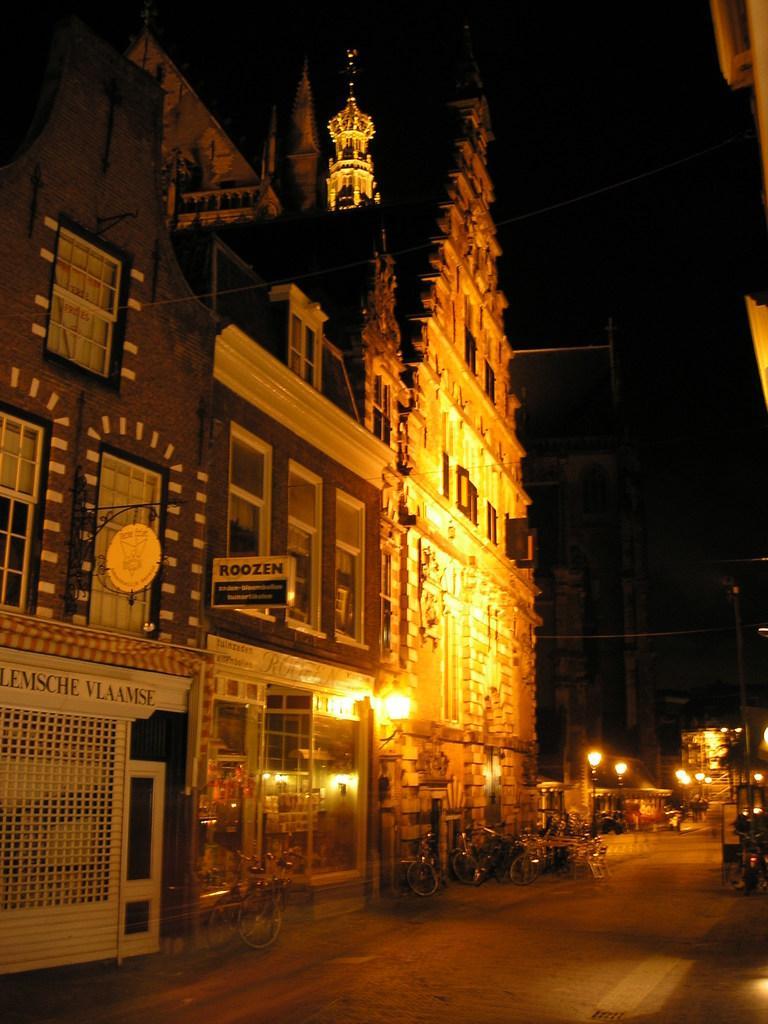In one or two sentences, can you explain what this image depicts? This image is taken during the night time. In this image we can see the buildings, light poles, lamp, text board and also the bicycles. We can also see the chairs and also the road. Sky is also visible. We can also see the wires. 